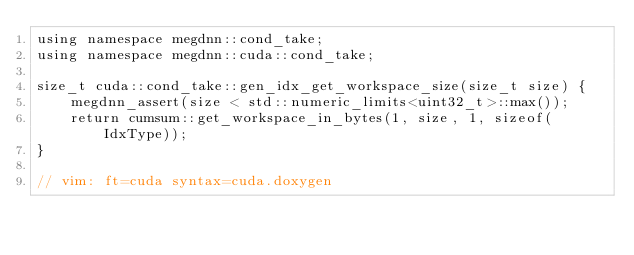Convert code to text. <code><loc_0><loc_0><loc_500><loc_500><_Cuda_>using namespace megdnn::cond_take;
using namespace megdnn::cuda::cond_take;

size_t cuda::cond_take::gen_idx_get_workspace_size(size_t size) {
    megdnn_assert(size < std::numeric_limits<uint32_t>::max());
    return cumsum::get_workspace_in_bytes(1, size, 1, sizeof(IdxType));
}

// vim: ft=cuda syntax=cuda.doxygen
</code> 